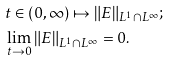Convert formula to latex. <formula><loc_0><loc_0><loc_500><loc_500>& t \in ( 0 , \infty ) \mapsto \| E \| _ { L ^ { 1 } \cap L ^ { \infty } } ; \\ & \lim _ { t \to 0 } \| E \| _ { L ^ { 1 } \cap L ^ { \infty } } = 0 .</formula> 